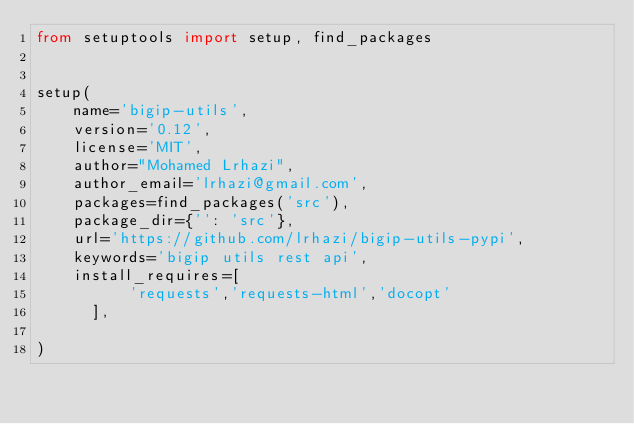<code> <loc_0><loc_0><loc_500><loc_500><_Python_>from setuptools import setup, find_packages


setup(
    name='bigip-utils',
    version='0.12',
    license='MIT',
    author="Mohamed Lrhazi",
    author_email='lrhazi@gmail.com',
    packages=find_packages('src'),
    package_dir={'': 'src'},
    url='https://github.com/lrhazi/bigip-utils-pypi',
    keywords='bigip utils rest api',
    install_requires=[
          'requests','requests-html','docopt'
      ],

)
</code> 